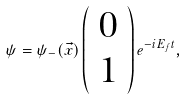<formula> <loc_0><loc_0><loc_500><loc_500>\psi = { \psi } _ { - } ( \vec { x } ) \left ( \begin{array} { c } { 0 } \\ { 1 } \end{array} \right ) e ^ { - i E _ { f } t } ,</formula> 